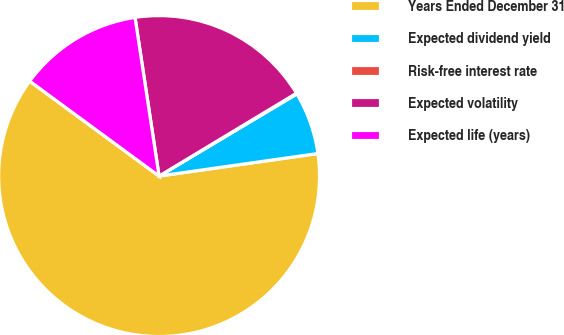Convert chart. <chart><loc_0><loc_0><loc_500><loc_500><pie_chart><fcel>Years Ended December 31<fcel>Expected dividend yield<fcel>Risk-free interest rate<fcel>Expected volatility<fcel>Expected life (years)<nl><fcel>62.32%<fcel>6.31%<fcel>0.08%<fcel>18.76%<fcel>12.53%<nl></chart> 